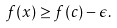<formula> <loc_0><loc_0><loc_500><loc_500>f ( x ) \geq f ( c ) - \epsilon .</formula> 